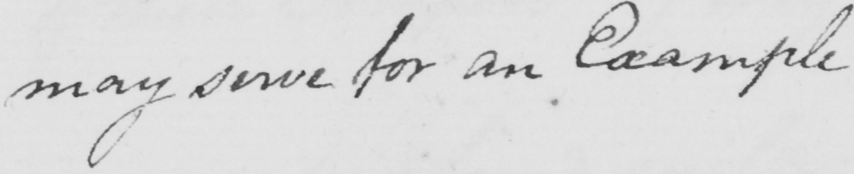Please transcribe the handwritten text in this image. may serve for an Example 